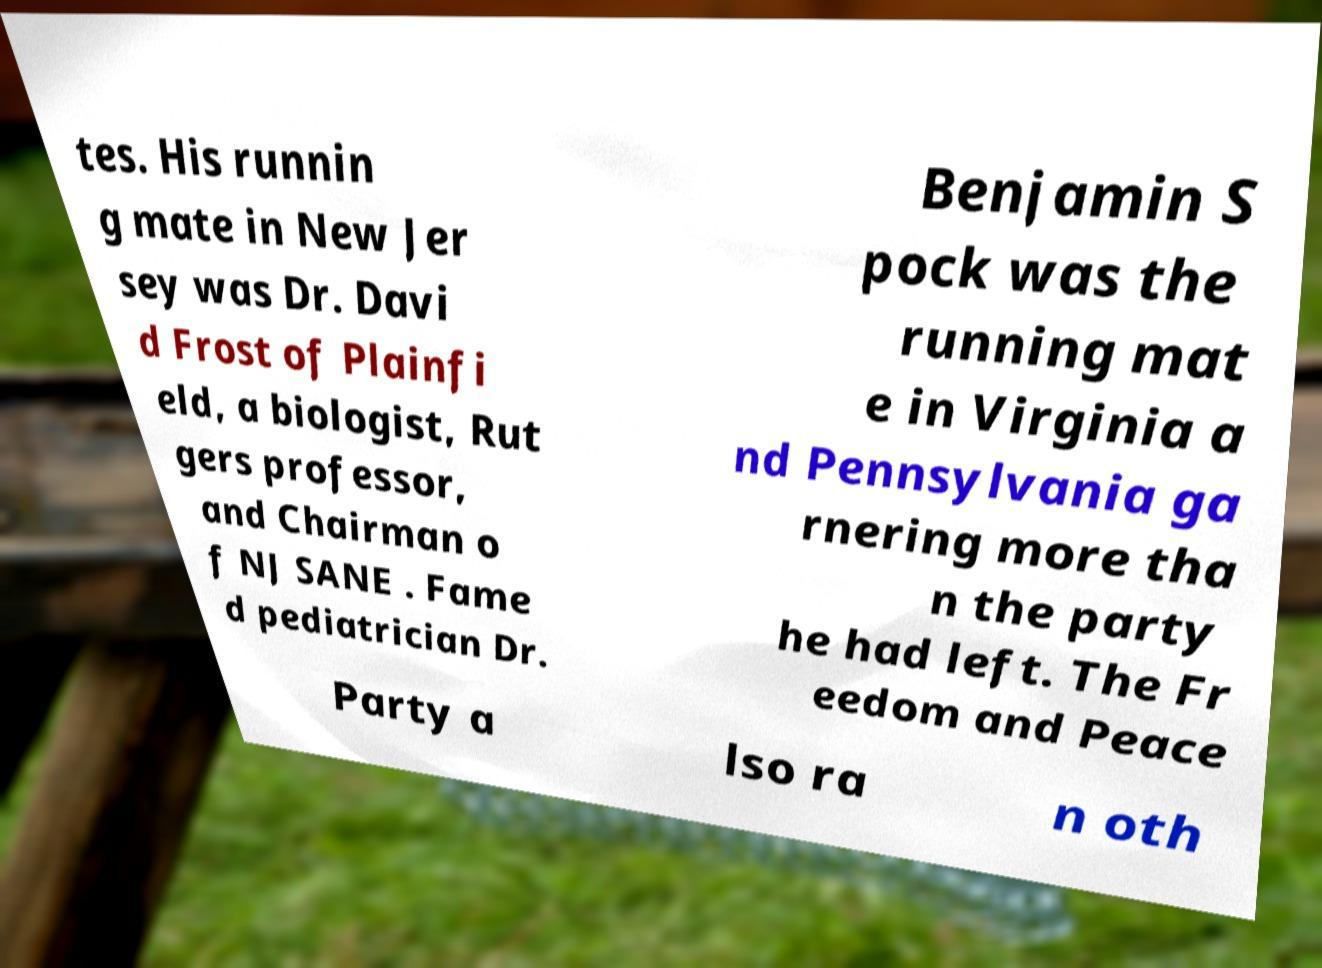Can you read and provide the text displayed in the image?This photo seems to have some interesting text. Can you extract and type it out for me? tes. His runnin g mate in New Jer sey was Dr. Davi d Frost of Plainfi eld, a biologist, Rut gers professor, and Chairman o f NJ SANE . Fame d pediatrician Dr. Benjamin S pock was the running mat e in Virginia a nd Pennsylvania ga rnering more tha n the party he had left. The Fr eedom and Peace Party a lso ra n oth 